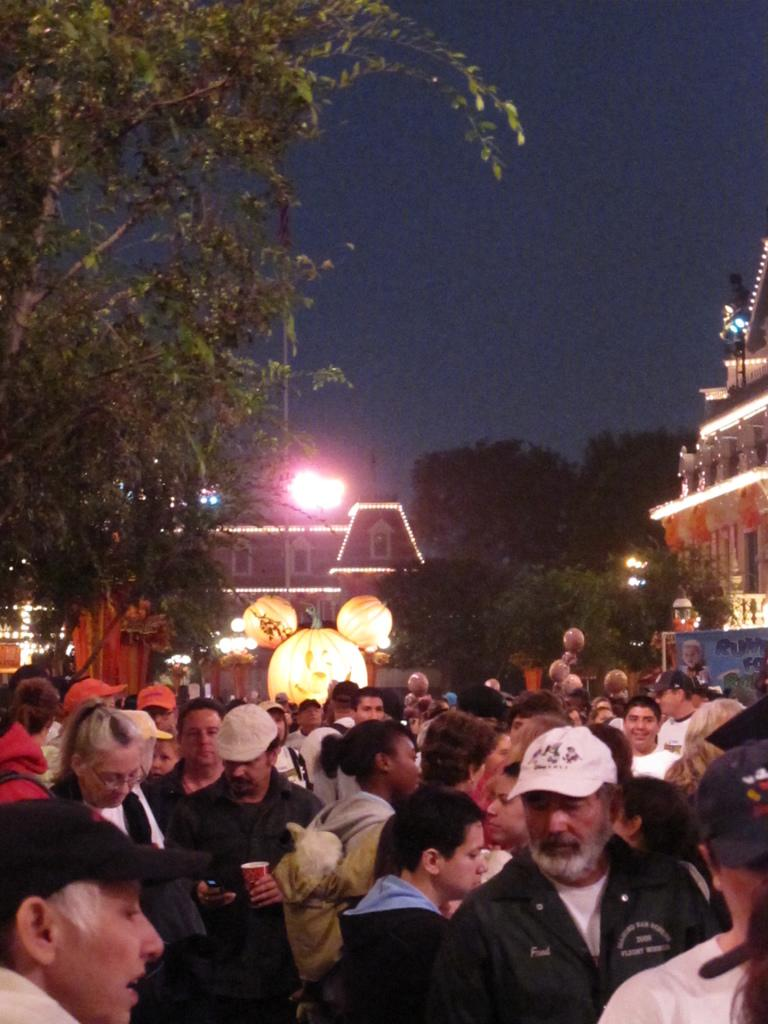How many people are in the image? There are persons in the image, but the exact number is not specified. What can be seen in the image besides the persons? There are lights, trees, buildings, a hoarding, and the sky visible in the image. What is the background of the image composed of? The background of the image includes trees, buildings, a hoarding, and the sky. What type of punishment is being handed out in the image? There is no indication of punishment in the image; it features persons, lights, trees, buildings, a hoarding, and the sky. What discovery was made by the persons in the image? There is no mention of a discovery in the image; it simply shows persons, lights, trees, buildings, a hoarding, and the sky. 